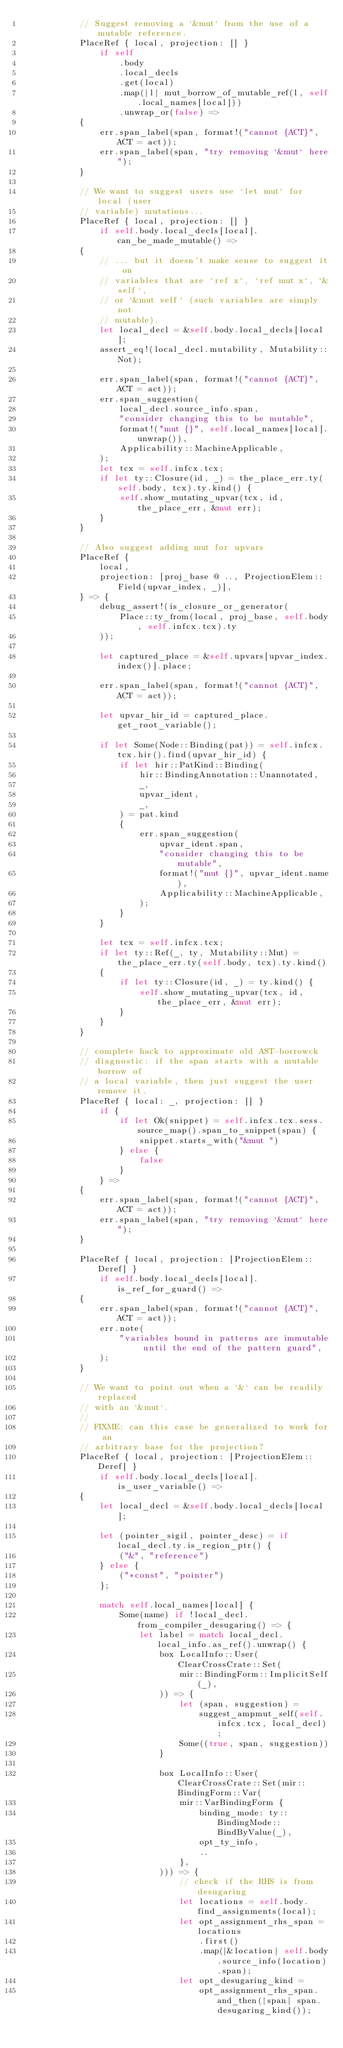Convert code to text. <code><loc_0><loc_0><loc_500><loc_500><_Rust_>            // Suggest removing a `&mut` from the use of a mutable reference.
            PlaceRef { local, projection: [] }
                if self
                    .body
                    .local_decls
                    .get(local)
                    .map(|l| mut_borrow_of_mutable_ref(l, self.local_names[local]))
                    .unwrap_or(false) =>
            {
                err.span_label(span, format!("cannot {ACT}", ACT = act));
                err.span_label(span, "try removing `&mut` here");
            }

            // We want to suggest users use `let mut` for local (user
            // variable) mutations...
            PlaceRef { local, projection: [] }
                if self.body.local_decls[local].can_be_made_mutable() =>
            {
                // ... but it doesn't make sense to suggest it on
                // variables that are `ref x`, `ref mut x`, `&self`,
                // or `&mut self` (such variables are simply not
                // mutable).
                let local_decl = &self.body.local_decls[local];
                assert_eq!(local_decl.mutability, Mutability::Not);

                err.span_label(span, format!("cannot {ACT}", ACT = act));
                err.span_suggestion(
                    local_decl.source_info.span,
                    "consider changing this to be mutable",
                    format!("mut {}", self.local_names[local].unwrap()),
                    Applicability::MachineApplicable,
                );
                let tcx = self.infcx.tcx;
                if let ty::Closure(id, _) = the_place_err.ty(self.body, tcx).ty.kind() {
                    self.show_mutating_upvar(tcx, id, the_place_err, &mut err);
                }
            }

            // Also suggest adding mut for upvars
            PlaceRef {
                local,
                projection: [proj_base @ .., ProjectionElem::Field(upvar_index, _)],
            } => {
                debug_assert!(is_closure_or_generator(
                    Place::ty_from(local, proj_base, self.body, self.infcx.tcx).ty
                ));

                let captured_place = &self.upvars[upvar_index.index()].place;

                err.span_label(span, format!("cannot {ACT}", ACT = act));

                let upvar_hir_id = captured_place.get_root_variable();

                if let Some(Node::Binding(pat)) = self.infcx.tcx.hir().find(upvar_hir_id) {
                    if let hir::PatKind::Binding(
                        hir::BindingAnnotation::Unannotated,
                        _,
                        upvar_ident,
                        _,
                    ) = pat.kind
                    {
                        err.span_suggestion(
                            upvar_ident.span,
                            "consider changing this to be mutable",
                            format!("mut {}", upvar_ident.name),
                            Applicability::MachineApplicable,
                        );
                    }
                }

                let tcx = self.infcx.tcx;
                if let ty::Ref(_, ty, Mutability::Mut) = the_place_err.ty(self.body, tcx).ty.kind()
                {
                    if let ty::Closure(id, _) = ty.kind() {
                        self.show_mutating_upvar(tcx, id, the_place_err, &mut err);
                    }
                }
            }

            // complete hack to approximate old AST-borrowck
            // diagnostic: if the span starts with a mutable borrow of
            // a local variable, then just suggest the user remove it.
            PlaceRef { local: _, projection: [] }
                if {
                    if let Ok(snippet) = self.infcx.tcx.sess.source_map().span_to_snippet(span) {
                        snippet.starts_with("&mut ")
                    } else {
                        false
                    }
                } =>
            {
                err.span_label(span, format!("cannot {ACT}", ACT = act));
                err.span_label(span, "try removing `&mut` here");
            }

            PlaceRef { local, projection: [ProjectionElem::Deref] }
                if self.body.local_decls[local].is_ref_for_guard() =>
            {
                err.span_label(span, format!("cannot {ACT}", ACT = act));
                err.note(
                    "variables bound in patterns are immutable until the end of the pattern guard",
                );
            }

            // We want to point out when a `&` can be readily replaced
            // with an `&mut`.
            //
            // FIXME: can this case be generalized to work for an
            // arbitrary base for the projection?
            PlaceRef { local, projection: [ProjectionElem::Deref] }
                if self.body.local_decls[local].is_user_variable() =>
            {
                let local_decl = &self.body.local_decls[local];

                let (pointer_sigil, pointer_desc) = if local_decl.ty.is_region_ptr() {
                    ("&", "reference")
                } else {
                    ("*const", "pointer")
                };

                match self.local_names[local] {
                    Some(name) if !local_decl.from_compiler_desugaring() => {
                        let label = match local_decl.local_info.as_ref().unwrap() {
                            box LocalInfo::User(ClearCrossCrate::Set(
                                mir::BindingForm::ImplicitSelf(_),
                            )) => {
                                let (span, suggestion) =
                                    suggest_ampmut_self(self.infcx.tcx, local_decl);
                                Some((true, span, suggestion))
                            }

                            box LocalInfo::User(ClearCrossCrate::Set(mir::BindingForm::Var(
                                mir::VarBindingForm {
                                    binding_mode: ty::BindingMode::BindByValue(_),
                                    opt_ty_info,
                                    ..
                                },
                            ))) => {
                                // check if the RHS is from desugaring
                                let locations = self.body.find_assignments(local);
                                let opt_assignment_rhs_span = locations
                                    .first()
                                    .map(|&location| self.body.source_info(location).span);
                                let opt_desugaring_kind =
                                    opt_assignment_rhs_span.and_then(|span| span.desugaring_kind());</code> 